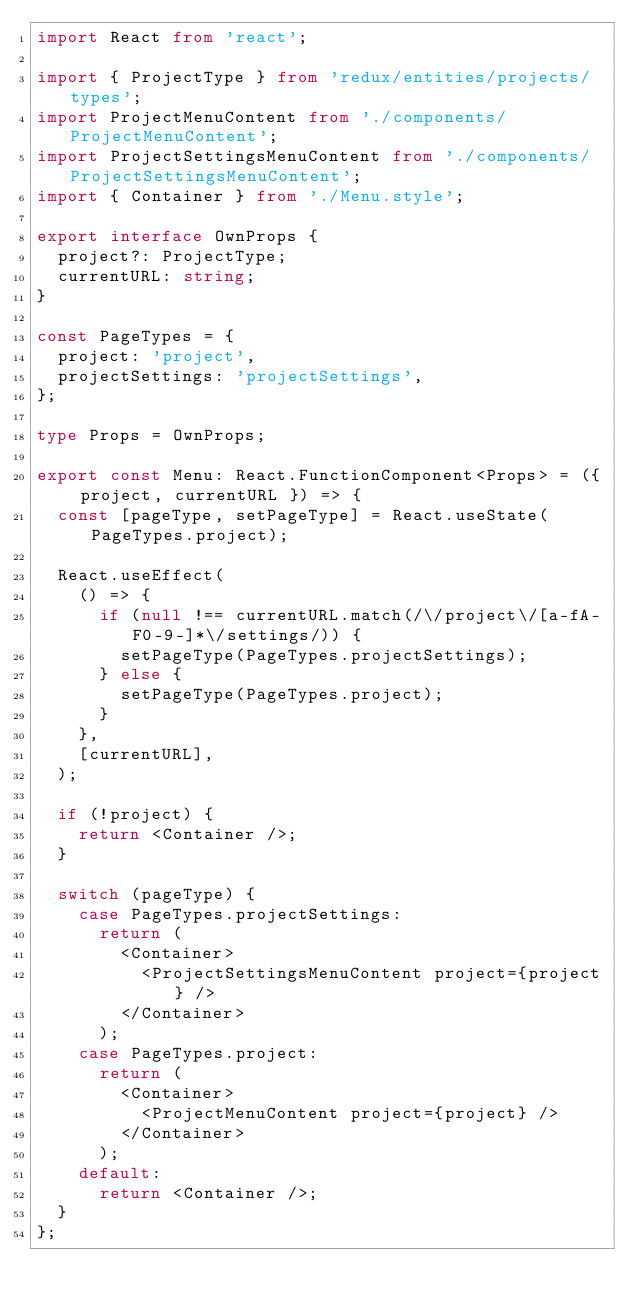Convert code to text. <code><loc_0><loc_0><loc_500><loc_500><_TypeScript_>import React from 'react';

import { ProjectType } from 'redux/entities/projects/types';
import ProjectMenuContent from './components/ProjectMenuContent';
import ProjectSettingsMenuContent from './components/ProjectSettingsMenuContent';
import { Container } from './Menu.style';

export interface OwnProps {
  project?: ProjectType;
  currentURL: string;
}

const PageTypes = {
  project: 'project',
  projectSettings: 'projectSettings',
};

type Props = OwnProps;

export const Menu: React.FunctionComponent<Props> = ({ project, currentURL }) => {
  const [pageType, setPageType] = React.useState(PageTypes.project);

  React.useEffect(
    () => {
      if (null !== currentURL.match(/\/project\/[a-fA-F0-9-]*\/settings/)) {
        setPageType(PageTypes.projectSettings);
      } else {
        setPageType(PageTypes.project);
      }
    },
    [currentURL],
  );

  if (!project) {
    return <Container />;
  }

  switch (pageType) {
    case PageTypes.projectSettings:
      return (
        <Container>
          <ProjectSettingsMenuContent project={project} />
        </Container>
      );
    case PageTypes.project:
      return (
        <Container>
          <ProjectMenuContent project={project} />
        </Container>
      );
    default:
      return <Container />;
  }
};
</code> 